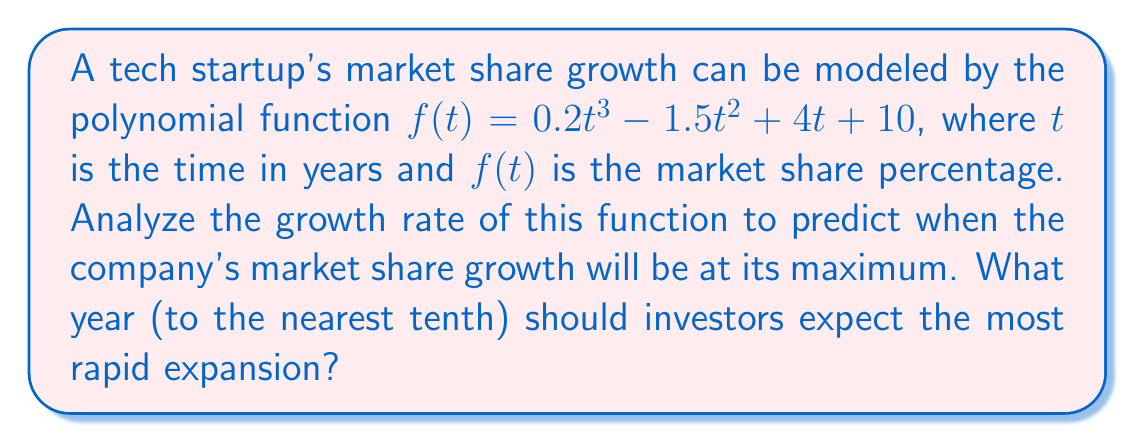What is the answer to this math problem? To find when the market share growth is at its maximum, we need to follow these steps:

1) The growth rate is represented by the first derivative of the function. Let's calculate $f'(t)$:
   
   $f'(t) = 0.6t^2 - 3t + 4$

2) The maximum growth rate occurs when the second derivative equals zero. Let's calculate $f''(t)$:
   
   $f''(t) = 1.2t - 3$

3) Set $f''(t) = 0$ and solve for $t$:
   
   $1.2t - 3 = 0$
   $1.2t = 3$
   $t = 2.5$

4) To confirm this is a maximum (not a minimum), we can check that $f'''(t) = 1.2 > 0$.

5) Therefore, the growth rate is maximized at $t = 2.5$ years.

6) Rounding to the nearest tenth: 2.5 years.
Answer: 2.5 years 